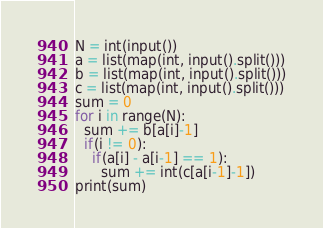<code> <loc_0><loc_0><loc_500><loc_500><_Python_>N = int(input())
a = list(map(int, input().split()))
b = list(map(int, input().split()))
c = list(map(int, input().split()))
sum = 0
for i in range(N):
  sum += b[a[i]-1]
  if(i != 0):
    if(a[i] - a[i-1] == 1):
      sum += int(c[a[i-1]-1])
print(sum)</code> 